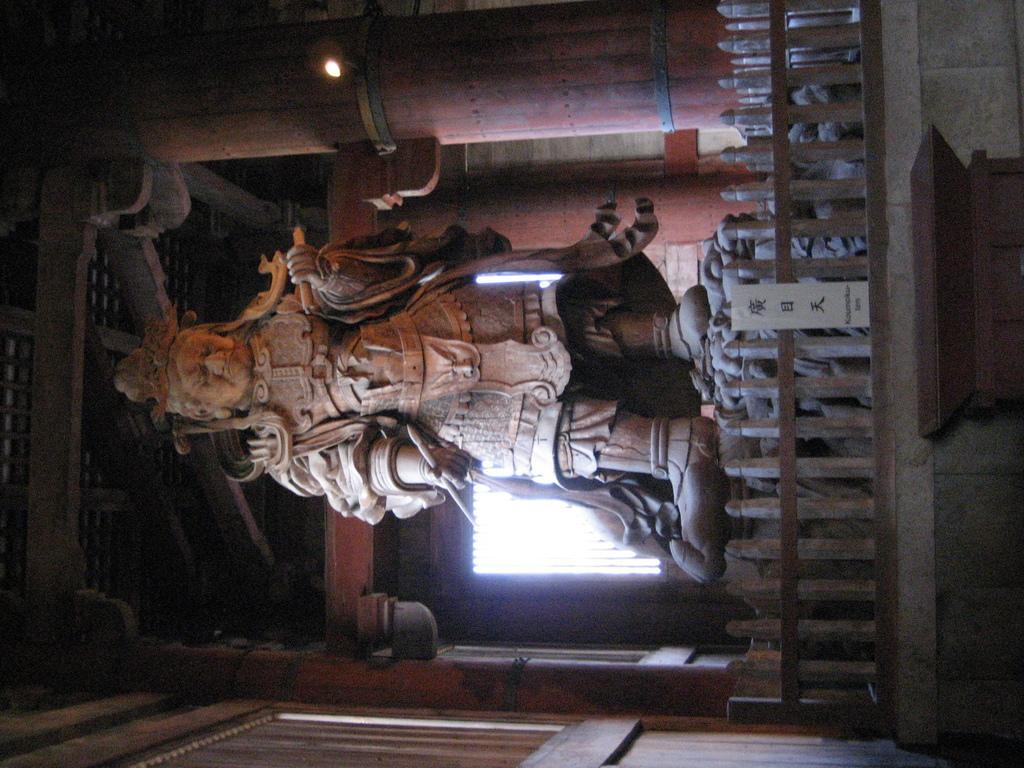Could you give a brief overview of what you see in this image? In this image we can see a statue. We can also see some pillars, a fence, a window and a roof. 